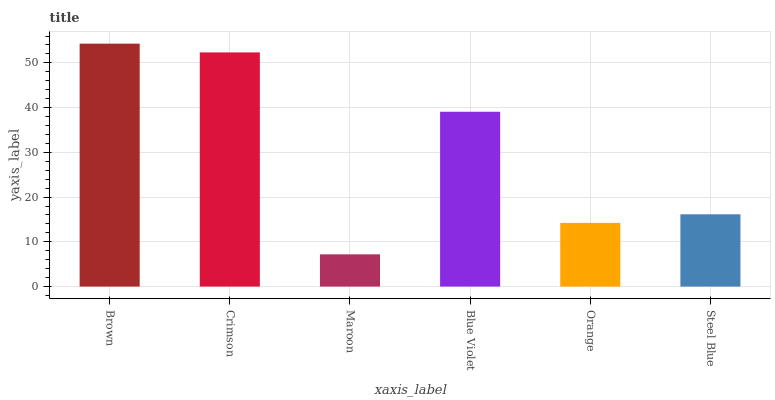Is Maroon the minimum?
Answer yes or no. Yes. Is Brown the maximum?
Answer yes or no. Yes. Is Crimson the minimum?
Answer yes or no. No. Is Crimson the maximum?
Answer yes or no. No. Is Brown greater than Crimson?
Answer yes or no. Yes. Is Crimson less than Brown?
Answer yes or no. Yes. Is Crimson greater than Brown?
Answer yes or no. No. Is Brown less than Crimson?
Answer yes or no. No. Is Blue Violet the high median?
Answer yes or no. Yes. Is Steel Blue the low median?
Answer yes or no. Yes. Is Maroon the high median?
Answer yes or no. No. Is Orange the low median?
Answer yes or no. No. 